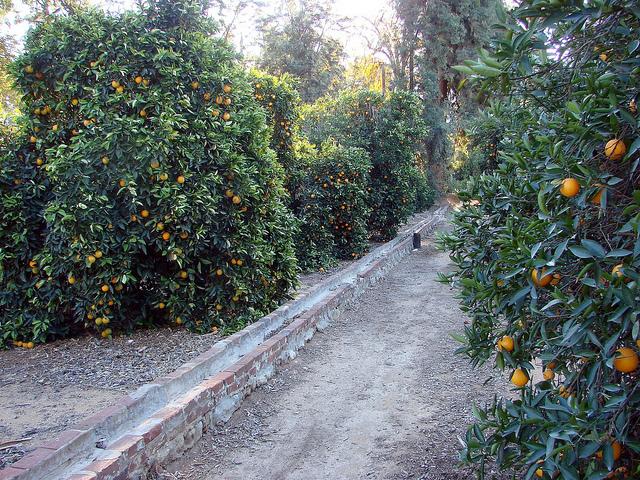Is this a forest?
Write a very short answer. No. Is it about harvesting time?
Give a very brief answer. Yes. Where are the oranges?
Write a very short answer. Trees. Is this an orange tree?
Answer briefly. Yes. 